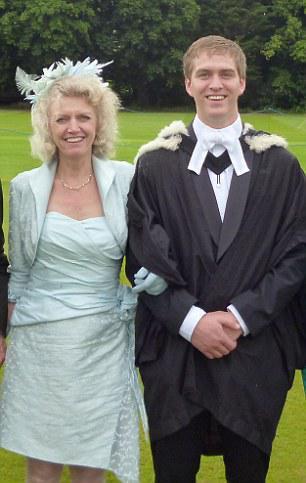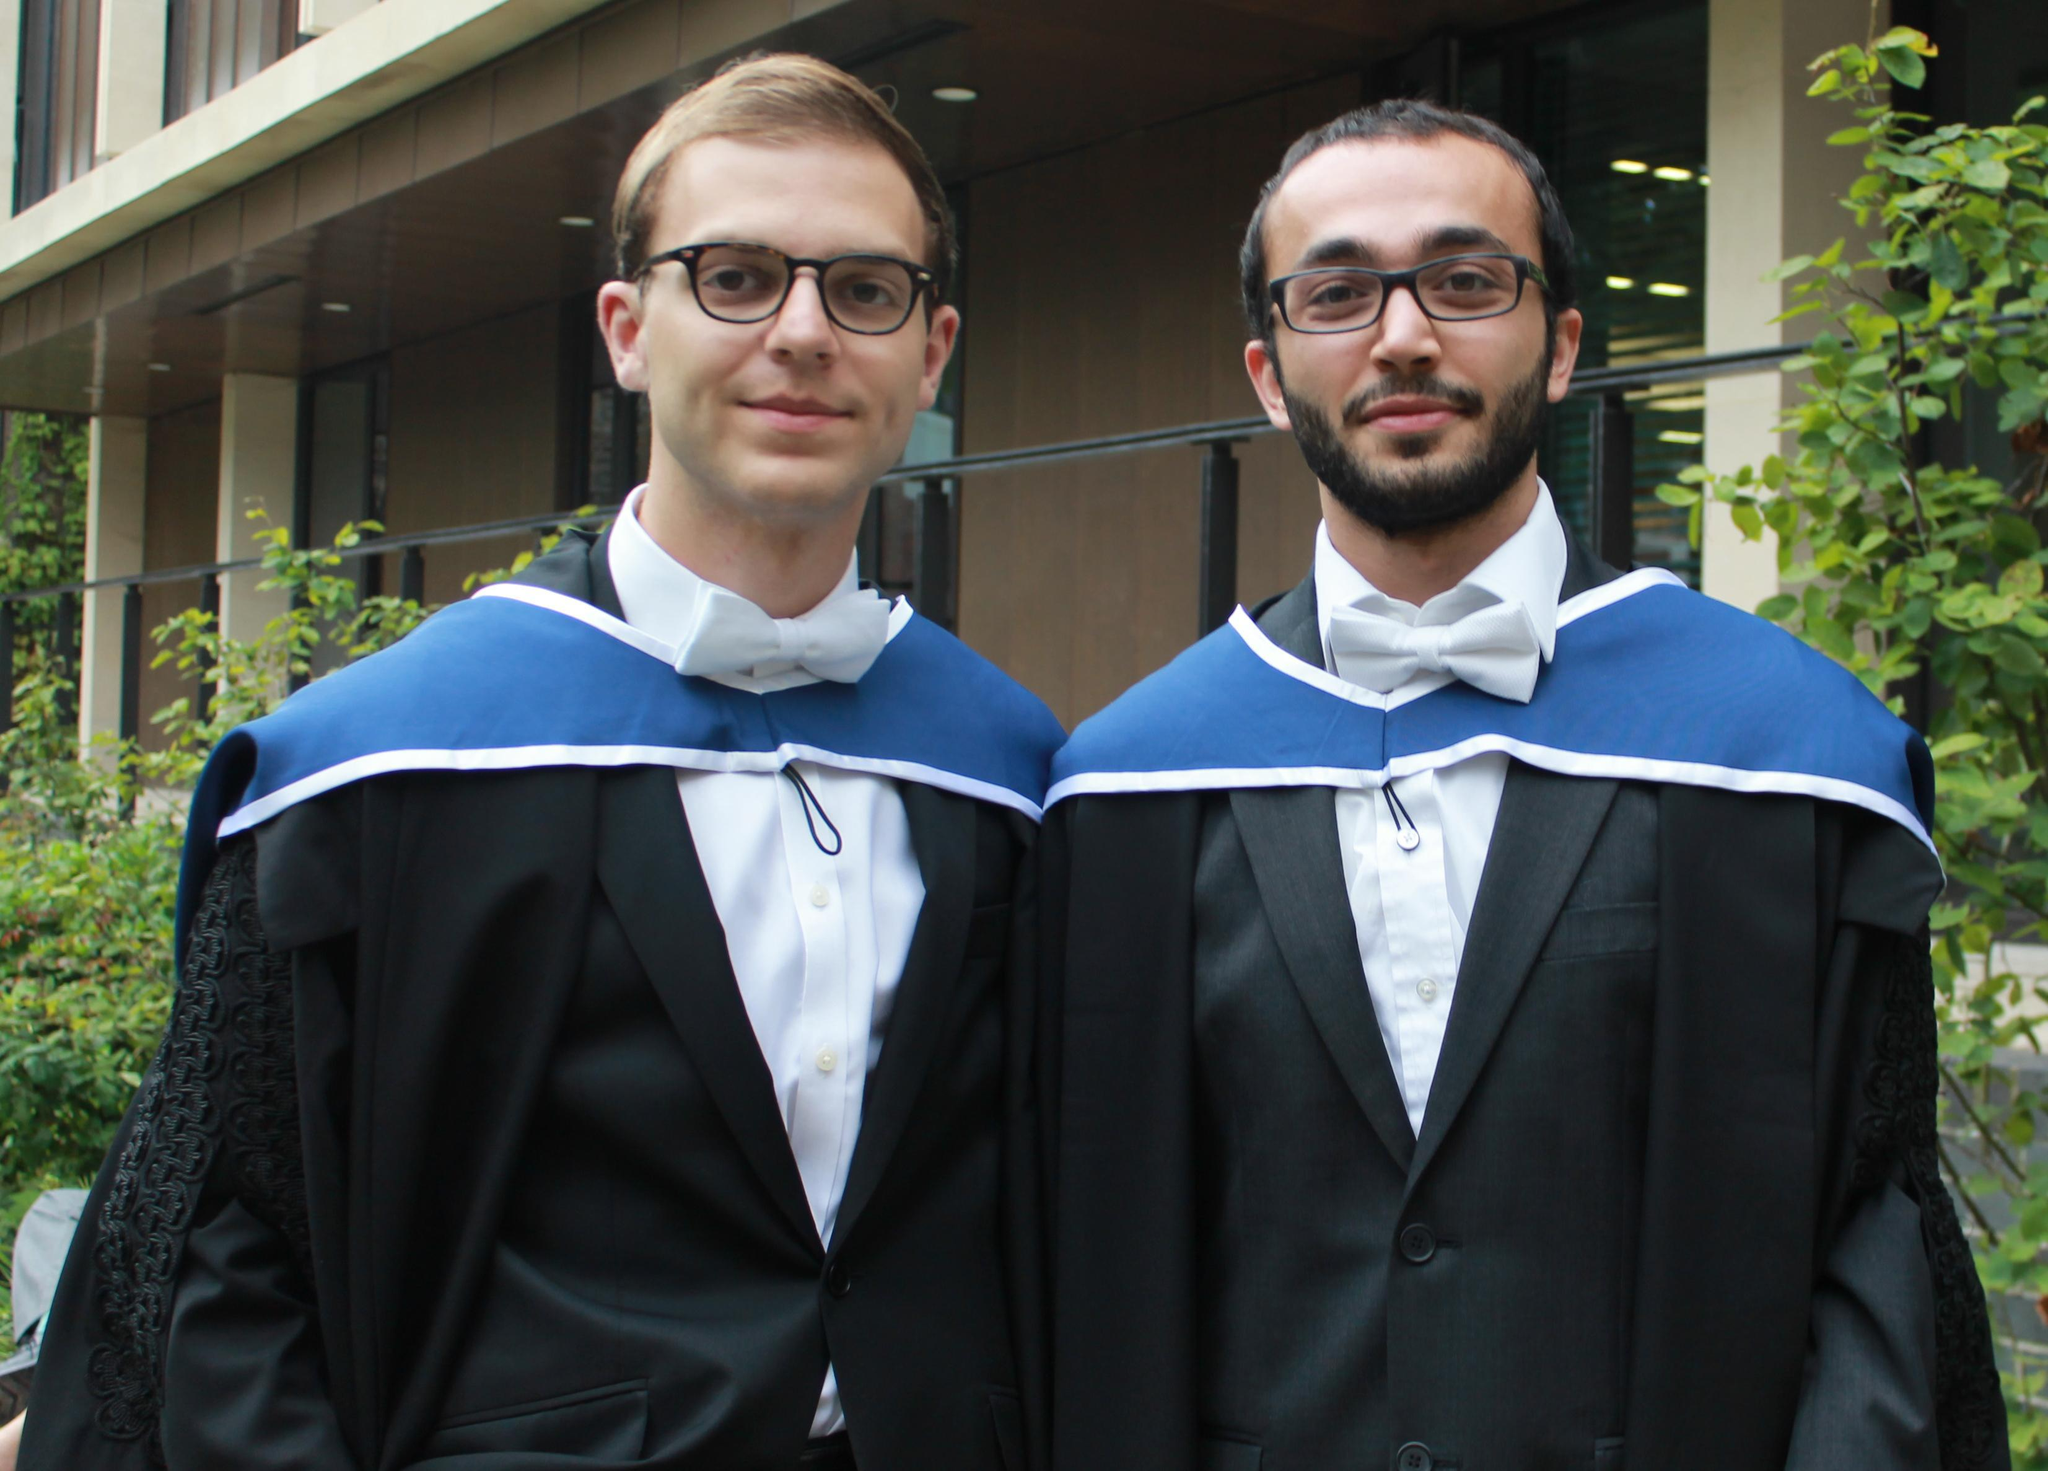The first image is the image on the left, the second image is the image on the right. Examine the images to the left and right. Is the description "An image shows only one person modeling graduation attire, a long-haired female who is not facing the camera." accurate? Answer yes or no. No. The first image is the image on the left, the second image is the image on the right. Given the left and right images, does the statement "An image contains more than one graduation student." hold true? Answer yes or no. Yes. 